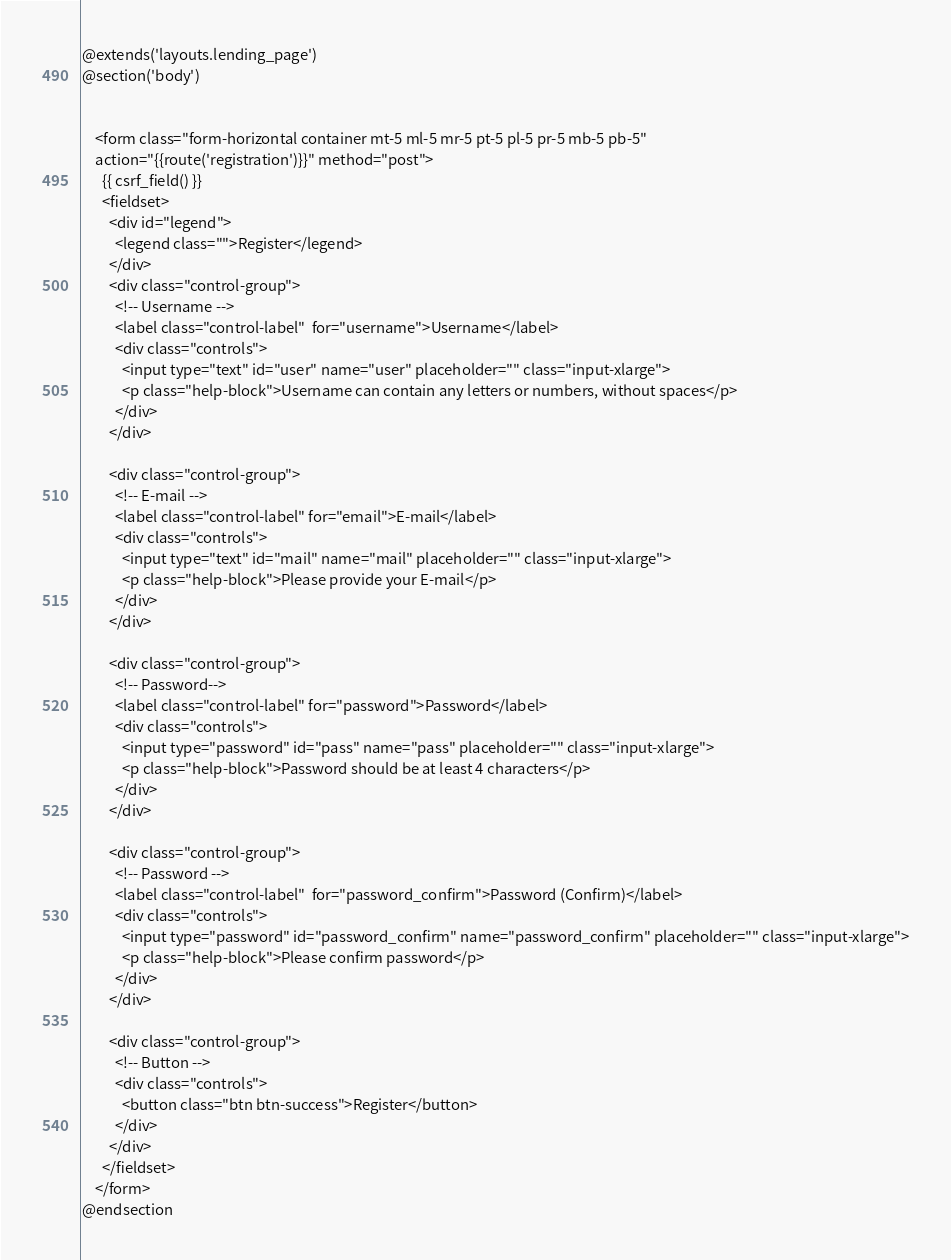Convert code to text. <code><loc_0><loc_0><loc_500><loc_500><_PHP_>@extends('layouts.lending_page')
@section('body')


	<form class="form-horizontal container mt-5 ml-5 mr-5 pt-5 pl-5 pr-5 mb-5 pb-5" 
	action="{{route('registration')}}" method="post">
	  {{ csrf_field() }}
	  <fieldset>
	    <div id="legend">
	      <legend class="">Register</legend>
	    </div>
	    <div class="control-group">
	      <!-- Username -->
	      <label class="control-label"  for="username">Username</label>
	      <div class="controls">
	        <input type="text" id="user" name="user" placeholder="" class="input-xlarge">
	        <p class="help-block">Username can contain any letters or numbers, without spaces</p>
	      </div>
	    </div>
	 
	    <div class="control-group">
	      <!-- E-mail -->
	      <label class="control-label" for="email">E-mail</label>
	      <div class="controls">
	        <input type="text" id="mail" name="mail" placeholder="" class="input-xlarge">
	        <p class="help-block">Please provide your E-mail</p>
	      </div>
	    </div>
	 
	    <div class="control-group">
	      <!-- Password-->
	      <label class="control-label" for="password">Password</label>
	      <div class="controls">
	        <input type="password" id="pass" name="pass" placeholder="" class="input-xlarge">
	        <p class="help-block">Password should be at least 4 characters</p>
	      </div>
	    </div>
	 
	    <div class="control-group">
	      <!-- Password -->
	      <label class="control-label"  for="password_confirm">Password (Confirm)</label>
	      <div class="controls">
	        <input type="password" id="password_confirm" name="password_confirm" placeholder="" class="input-xlarge">
	        <p class="help-block">Please confirm password</p>
	      </div>
	    </div>
	 
	    <div class="control-group">
	      <!-- Button -->
	      <div class="controls">
	        <button class="btn btn-success">Register</button>
	      </div>
	    </div>
	  </fieldset>
	</form>
@endsection
</code> 